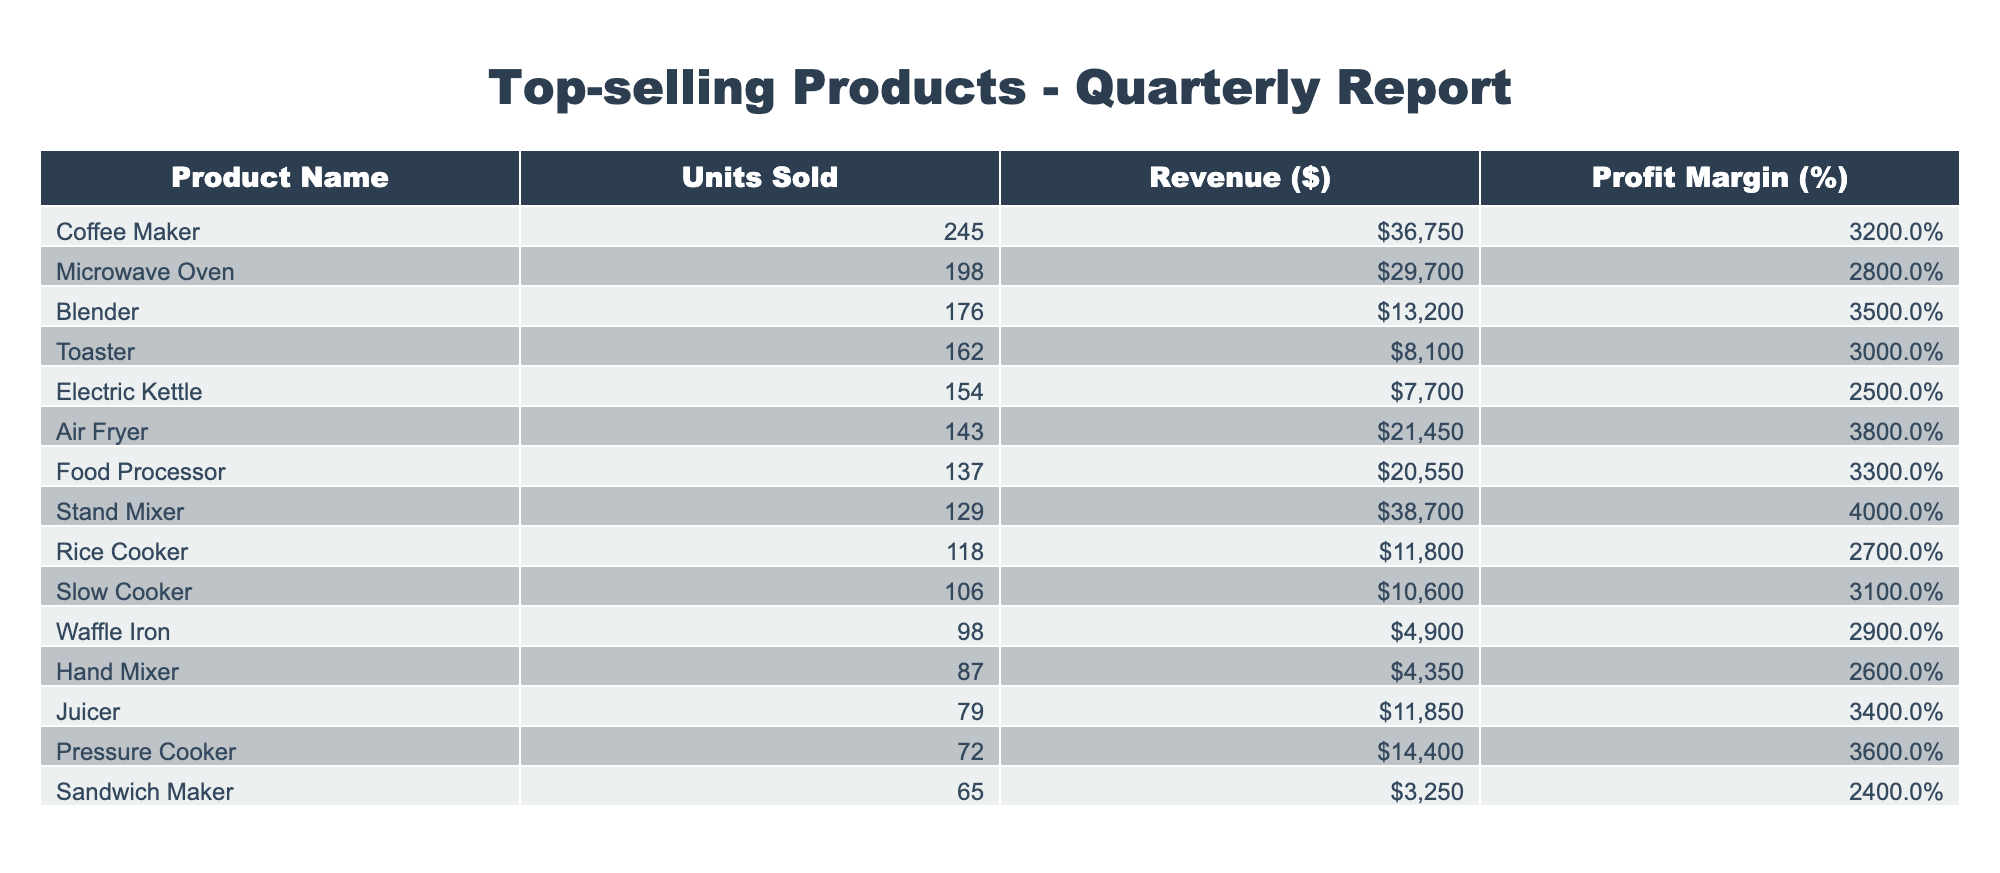What is the product with the highest revenue? By examining the Revenue column, the product with the highest revenue can be easily identified. The Coffee Maker has a revenue of $36,750, which is higher than all other products.
Answer: Coffee Maker How many units of the Air Fryer were sold? Looking at the Units Sold column, the Air Fryer shows a value of 143. This directly indicates the number of units sold for that product.
Answer: 143 What is the average profit margin of the top three products? The top three products by units sold are the Coffee Maker, Microwave Oven, and Blender with profit margins of 32%, 28%, and 35% respectively. To calculate the average, add these margins: 32 + 28 + 35 = 95. Divide by 3 to find the average: 95/3 = 31.67%.
Answer: 31.67% Is the profit margin of the Rice Cooker greater than the profit margin of the Slow Cooker? The Rice Cooker has a profit margin of 27% while the Slow Cooker has a margin of 31%. Since 27% is less than 31%, the statement is false.
Answer: No What is the total revenue generated from the Food Processor and Stand Mixer combined? The revenue from the Food Processor is $20,550 and from the Stand Mixer is $38,700. Adding these two amounts gives: 20,550 + 38,700 = 59,250. This results in the total revenue from these two products.
Answer: $59,250 Which product had the least number of units sold? By inspecting the Units Sold column, you can see that the Sandwich Maker sold the least at 65 units.
Answer: Sandwich Maker Do more units of Blenders or Juicers sell in total? The Blender sold 176 units while the Juicer sold 79 units. Comparing the two, 176 is greater than 79, meaning more Blenders were sold.
Answer: Blenders What percentage of units sold were Electric Kettles? The total number of units sold across all products is the sum of all unit sales: 245 + 198 + 176 + 162 + 154 + 143 + 137 + 129 + 118 + 106 + 98 + 87 + 79 + 72 + 65 = 1,637. The number of Electric Kettles sold is 154. To find the percentage, divide 154 by 1,637 and multiply by 100: (154/1637) * 100 = 9.41%.
Answer: 9.41% 